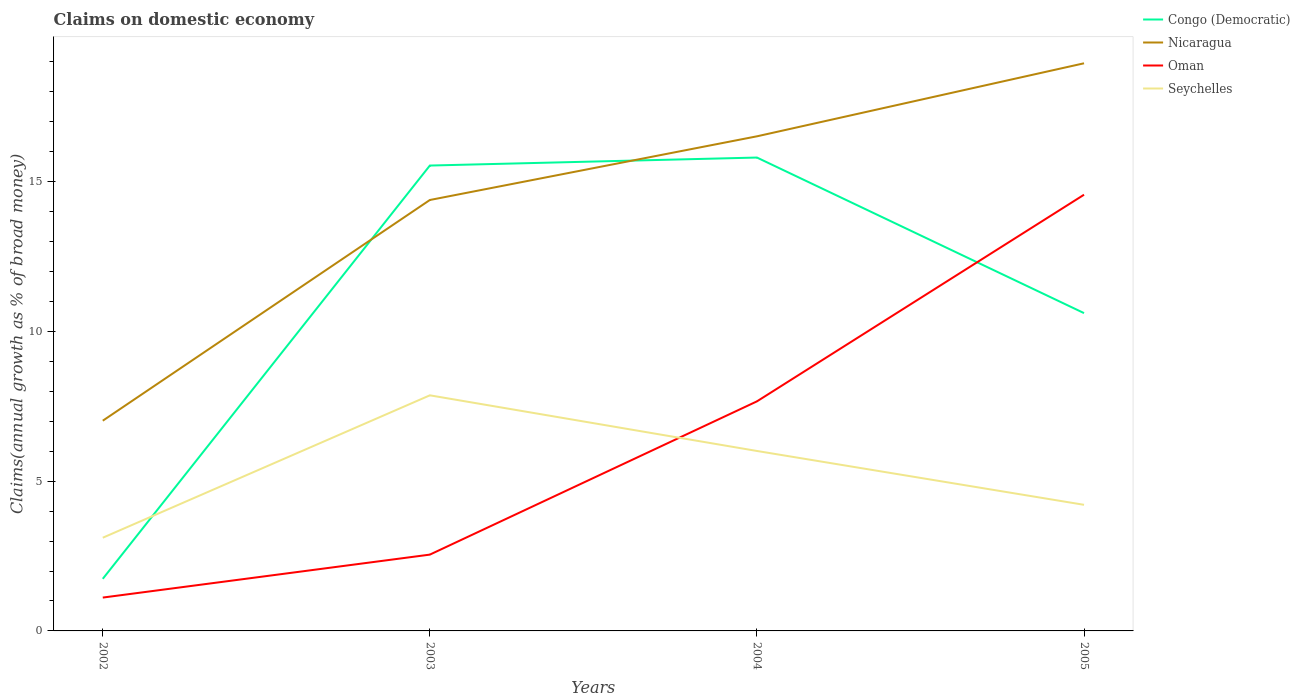Does the line corresponding to Nicaragua intersect with the line corresponding to Seychelles?
Your response must be concise. No. Across all years, what is the maximum percentage of broad money claimed on domestic economy in Oman?
Your response must be concise. 1.11. In which year was the percentage of broad money claimed on domestic economy in Oman maximum?
Give a very brief answer. 2002. What is the total percentage of broad money claimed on domestic economy in Congo (Democratic) in the graph?
Your answer should be compact. -14.06. What is the difference between the highest and the second highest percentage of broad money claimed on domestic economy in Seychelles?
Provide a succinct answer. 4.75. What is the difference between the highest and the lowest percentage of broad money claimed on domestic economy in Congo (Democratic)?
Your answer should be compact. 2. Are the values on the major ticks of Y-axis written in scientific E-notation?
Your answer should be very brief. No. Does the graph contain grids?
Give a very brief answer. No. How many legend labels are there?
Your answer should be very brief. 4. What is the title of the graph?
Offer a very short reply. Claims on domestic economy. Does "Bulgaria" appear as one of the legend labels in the graph?
Your response must be concise. No. What is the label or title of the Y-axis?
Your answer should be very brief. Claims(annual growth as % of broad money). What is the Claims(annual growth as % of broad money) of Congo (Democratic) in 2002?
Provide a succinct answer. 1.74. What is the Claims(annual growth as % of broad money) of Nicaragua in 2002?
Your answer should be compact. 7.02. What is the Claims(annual growth as % of broad money) in Oman in 2002?
Offer a very short reply. 1.11. What is the Claims(annual growth as % of broad money) in Seychelles in 2002?
Provide a succinct answer. 3.11. What is the Claims(annual growth as % of broad money) in Congo (Democratic) in 2003?
Make the answer very short. 15.53. What is the Claims(annual growth as % of broad money) of Nicaragua in 2003?
Provide a succinct answer. 14.38. What is the Claims(annual growth as % of broad money) in Oman in 2003?
Your answer should be very brief. 2.55. What is the Claims(annual growth as % of broad money) of Seychelles in 2003?
Give a very brief answer. 7.86. What is the Claims(annual growth as % of broad money) in Congo (Democratic) in 2004?
Your answer should be very brief. 15.8. What is the Claims(annual growth as % of broad money) in Nicaragua in 2004?
Make the answer very short. 16.51. What is the Claims(annual growth as % of broad money) of Oman in 2004?
Your response must be concise. 7.66. What is the Claims(annual growth as % of broad money) of Seychelles in 2004?
Give a very brief answer. 6.01. What is the Claims(annual growth as % of broad money) in Congo (Democratic) in 2005?
Give a very brief answer. 10.61. What is the Claims(annual growth as % of broad money) in Nicaragua in 2005?
Keep it short and to the point. 18.95. What is the Claims(annual growth as % of broad money) of Oman in 2005?
Make the answer very short. 14.56. What is the Claims(annual growth as % of broad money) in Seychelles in 2005?
Ensure brevity in your answer.  4.21. Across all years, what is the maximum Claims(annual growth as % of broad money) of Congo (Democratic)?
Offer a very short reply. 15.8. Across all years, what is the maximum Claims(annual growth as % of broad money) of Nicaragua?
Keep it short and to the point. 18.95. Across all years, what is the maximum Claims(annual growth as % of broad money) of Oman?
Keep it short and to the point. 14.56. Across all years, what is the maximum Claims(annual growth as % of broad money) of Seychelles?
Keep it short and to the point. 7.86. Across all years, what is the minimum Claims(annual growth as % of broad money) in Congo (Democratic)?
Ensure brevity in your answer.  1.74. Across all years, what is the minimum Claims(annual growth as % of broad money) of Nicaragua?
Offer a very short reply. 7.02. Across all years, what is the minimum Claims(annual growth as % of broad money) in Oman?
Offer a terse response. 1.11. Across all years, what is the minimum Claims(annual growth as % of broad money) of Seychelles?
Your answer should be compact. 3.11. What is the total Claims(annual growth as % of broad money) of Congo (Democratic) in the graph?
Make the answer very short. 43.68. What is the total Claims(annual growth as % of broad money) of Nicaragua in the graph?
Ensure brevity in your answer.  56.86. What is the total Claims(annual growth as % of broad money) of Oman in the graph?
Keep it short and to the point. 25.88. What is the total Claims(annual growth as % of broad money) of Seychelles in the graph?
Your response must be concise. 21.19. What is the difference between the Claims(annual growth as % of broad money) in Congo (Democratic) in 2002 and that in 2003?
Your answer should be compact. -13.79. What is the difference between the Claims(annual growth as % of broad money) of Nicaragua in 2002 and that in 2003?
Provide a short and direct response. -7.37. What is the difference between the Claims(annual growth as % of broad money) in Oman in 2002 and that in 2003?
Ensure brevity in your answer.  -1.43. What is the difference between the Claims(annual growth as % of broad money) of Seychelles in 2002 and that in 2003?
Ensure brevity in your answer.  -4.75. What is the difference between the Claims(annual growth as % of broad money) in Congo (Democratic) in 2002 and that in 2004?
Your answer should be compact. -14.06. What is the difference between the Claims(annual growth as % of broad money) of Nicaragua in 2002 and that in 2004?
Provide a short and direct response. -9.49. What is the difference between the Claims(annual growth as % of broad money) in Oman in 2002 and that in 2004?
Offer a very short reply. -6.55. What is the difference between the Claims(annual growth as % of broad money) of Seychelles in 2002 and that in 2004?
Offer a very short reply. -2.9. What is the difference between the Claims(annual growth as % of broad money) in Congo (Democratic) in 2002 and that in 2005?
Offer a very short reply. -8.87. What is the difference between the Claims(annual growth as % of broad money) in Nicaragua in 2002 and that in 2005?
Give a very brief answer. -11.93. What is the difference between the Claims(annual growth as % of broad money) of Oman in 2002 and that in 2005?
Keep it short and to the point. -13.45. What is the difference between the Claims(annual growth as % of broad money) of Seychelles in 2002 and that in 2005?
Your response must be concise. -1.1. What is the difference between the Claims(annual growth as % of broad money) in Congo (Democratic) in 2003 and that in 2004?
Your answer should be compact. -0.27. What is the difference between the Claims(annual growth as % of broad money) in Nicaragua in 2003 and that in 2004?
Your answer should be very brief. -2.13. What is the difference between the Claims(annual growth as % of broad money) in Oman in 2003 and that in 2004?
Ensure brevity in your answer.  -5.12. What is the difference between the Claims(annual growth as % of broad money) in Seychelles in 2003 and that in 2004?
Offer a very short reply. 1.86. What is the difference between the Claims(annual growth as % of broad money) in Congo (Democratic) in 2003 and that in 2005?
Provide a short and direct response. 4.93. What is the difference between the Claims(annual growth as % of broad money) of Nicaragua in 2003 and that in 2005?
Your answer should be compact. -4.56. What is the difference between the Claims(annual growth as % of broad money) in Oman in 2003 and that in 2005?
Provide a succinct answer. -12.01. What is the difference between the Claims(annual growth as % of broad money) in Seychelles in 2003 and that in 2005?
Your response must be concise. 3.65. What is the difference between the Claims(annual growth as % of broad money) in Congo (Democratic) in 2004 and that in 2005?
Make the answer very short. 5.19. What is the difference between the Claims(annual growth as % of broad money) in Nicaragua in 2004 and that in 2005?
Your answer should be compact. -2.44. What is the difference between the Claims(annual growth as % of broad money) of Oman in 2004 and that in 2005?
Offer a terse response. -6.9. What is the difference between the Claims(annual growth as % of broad money) in Seychelles in 2004 and that in 2005?
Make the answer very short. 1.8. What is the difference between the Claims(annual growth as % of broad money) of Congo (Democratic) in 2002 and the Claims(annual growth as % of broad money) of Nicaragua in 2003?
Give a very brief answer. -12.64. What is the difference between the Claims(annual growth as % of broad money) in Congo (Democratic) in 2002 and the Claims(annual growth as % of broad money) in Oman in 2003?
Your response must be concise. -0.81. What is the difference between the Claims(annual growth as % of broad money) of Congo (Democratic) in 2002 and the Claims(annual growth as % of broad money) of Seychelles in 2003?
Your answer should be compact. -6.12. What is the difference between the Claims(annual growth as % of broad money) in Nicaragua in 2002 and the Claims(annual growth as % of broad money) in Oman in 2003?
Provide a succinct answer. 4.47. What is the difference between the Claims(annual growth as % of broad money) in Nicaragua in 2002 and the Claims(annual growth as % of broad money) in Seychelles in 2003?
Offer a terse response. -0.85. What is the difference between the Claims(annual growth as % of broad money) of Oman in 2002 and the Claims(annual growth as % of broad money) of Seychelles in 2003?
Keep it short and to the point. -6.75. What is the difference between the Claims(annual growth as % of broad money) of Congo (Democratic) in 2002 and the Claims(annual growth as % of broad money) of Nicaragua in 2004?
Your answer should be compact. -14.77. What is the difference between the Claims(annual growth as % of broad money) of Congo (Democratic) in 2002 and the Claims(annual growth as % of broad money) of Oman in 2004?
Offer a very short reply. -5.92. What is the difference between the Claims(annual growth as % of broad money) in Congo (Democratic) in 2002 and the Claims(annual growth as % of broad money) in Seychelles in 2004?
Provide a succinct answer. -4.27. What is the difference between the Claims(annual growth as % of broad money) of Nicaragua in 2002 and the Claims(annual growth as % of broad money) of Oman in 2004?
Give a very brief answer. -0.65. What is the difference between the Claims(annual growth as % of broad money) in Nicaragua in 2002 and the Claims(annual growth as % of broad money) in Seychelles in 2004?
Your response must be concise. 1.01. What is the difference between the Claims(annual growth as % of broad money) in Oman in 2002 and the Claims(annual growth as % of broad money) in Seychelles in 2004?
Your answer should be very brief. -4.89. What is the difference between the Claims(annual growth as % of broad money) in Congo (Democratic) in 2002 and the Claims(annual growth as % of broad money) in Nicaragua in 2005?
Give a very brief answer. -17.21. What is the difference between the Claims(annual growth as % of broad money) of Congo (Democratic) in 2002 and the Claims(annual growth as % of broad money) of Oman in 2005?
Offer a terse response. -12.82. What is the difference between the Claims(annual growth as % of broad money) of Congo (Democratic) in 2002 and the Claims(annual growth as % of broad money) of Seychelles in 2005?
Keep it short and to the point. -2.47. What is the difference between the Claims(annual growth as % of broad money) of Nicaragua in 2002 and the Claims(annual growth as % of broad money) of Oman in 2005?
Your response must be concise. -7.54. What is the difference between the Claims(annual growth as % of broad money) in Nicaragua in 2002 and the Claims(annual growth as % of broad money) in Seychelles in 2005?
Ensure brevity in your answer.  2.81. What is the difference between the Claims(annual growth as % of broad money) in Oman in 2002 and the Claims(annual growth as % of broad money) in Seychelles in 2005?
Offer a very short reply. -3.1. What is the difference between the Claims(annual growth as % of broad money) in Congo (Democratic) in 2003 and the Claims(annual growth as % of broad money) in Nicaragua in 2004?
Your response must be concise. -0.98. What is the difference between the Claims(annual growth as % of broad money) of Congo (Democratic) in 2003 and the Claims(annual growth as % of broad money) of Oman in 2004?
Provide a short and direct response. 7.87. What is the difference between the Claims(annual growth as % of broad money) in Congo (Democratic) in 2003 and the Claims(annual growth as % of broad money) in Seychelles in 2004?
Make the answer very short. 9.53. What is the difference between the Claims(annual growth as % of broad money) in Nicaragua in 2003 and the Claims(annual growth as % of broad money) in Oman in 2004?
Your answer should be compact. 6.72. What is the difference between the Claims(annual growth as % of broad money) of Nicaragua in 2003 and the Claims(annual growth as % of broad money) of Seychelles in 2004?
Your response must be concise. 8.38. What is the difference between the Claims(annual growth as % of broad money) of Oman in 2003 and the Claims(annual growth as % of broad money) of Seychelles in 2004?
Offer a very short reply. -3.46. What is the difference between the Claims(annual growth as % of broad money) of Congo (Democratic) in 2003 and the Claims(annual growth as % of broad money) of Nicaragua in 2005?
Make the answer very short. -3.41. What is the difference between the Claims(annual growth as % of broad money) in Congo (Democratic) in 2003 and the Claims(annual growth as % of broad money) in Oman in 2005?
Your response must be concise. 0.97. What is the difference between the Claims(annual growth as % of broad money) of Congo (Democratic) in 2003 and the Claims(annual growth as % of broad money) of Seychelles in 2005?
Keep it short and to the point. 11.32. What is the difference between the Claims(annual growth as % of broad money) of Nicaragua in 2003 and the Claims(annual growth as % of broad money) of Oman in 2005?
Your answer should be compact. -0.18. What is the difference between the Claims(annual growth as % of broad money) in Nicaragua in 2003 and the Claims(annual growth as % of broad money) in Seychelles in 2005?
Give a very brief answer. 10.17. What is the difference between the Claims(annual growth as % of broad money) of Oman in 2003 and the Claims(annual growth as % of broad money) of Seychelles in 2005?
Provide a short and direct response. -1.66. What is the difference between the Claims(annual growth as % of broad money) in Congo (Democratic) in 2004 and the Claims(annual growth as % of broad money) in Nicaragua in 2005?
Offer a very short reply. -3.15. What is the difference between the Claims(annual growth as % of broad money) of Congo (Democratic) in 2004 and the Claims(annual growth as % of broad money) of Oman in 2005?
Give a very brief answer. 1.24. What is the difference between the Claims(annual growth as % of broad money) of Congo (Democratic) in 2004 and the Claims(annual growth as % of broad money) of Seychelles in 2005?
Provide a succinct answer. 11.59. What is the difference between the Claims(annual growth as % of broad money) in Nicaragua in 2004 and the Claims(annual growth as % of broad money) in Oman in 2005?
Provide a short and direct response. 1.95. What is the difference between the Claims(annual growth as % of broad money) of Nicaragua in 2004 and the Claims(annual growth as % of broad money) of Seychelles in 2005?
Offer a terse response. 12.3. What is the difference between the Claims(annual growth as % of broad money) of Oman in 2004 and the Claims(annual growth as % of broad money) of Seychelles in 2005?
Your answer should be very brief. 3.45. What is the average Claims(annual growth as % of broad money) in Congo (Democratic) per year?
Ensure brevity in your answer.  10.92. What is the average Claims(annual growth as % of broad money) of Nicaragua per year?
Provide a short and direct response. 14.21. What is the average Claims(annual growth as % of broad money) of Oman per year?
Make the answer very short. 6.47. What is the average Claims(annual growth as % of broad money) of Seychelles per year?
Offer a terse response. 5.3. In the year 2002, what is the difference between the Claims(annual growth as % of broad money) in Congo (Democratic) and Claims(annual growth as % of broad money) in Nicaragua?
Offer a terse response. -5.28. In the year 2002, what is the difference between the Claims(annual growth as % of broad money) in Congo (Democratic) and Claims(annual growth as % of broad money) in Oman?
Make the answer very short. 0.63. In the year 2002, what is the difference between the Claims(annual growth as % of broad money) in Congo (Democratic) and Claims(annual growth as % of broad money) in Seychelles?
Provide a succinct answer. -1.37. In the year 2002, what is the difference between the Claims(annual growth as % of broad money) of Nicaragua and Claims(annual growth as % of broad money) of Oman?
Provide a succinct answer. 5.9. In the year 2002, what is the difference between the Claims(annual growth as % of broad money) of Nicaragua and Claims(annual growth as % of broad money) of Seychelles?
Ensure brevity in your answer.  3.91. In the year 2002, what is the difference between the Claims(annual growth as % of broad money) in Oman and Claims(annual growth as % of broad money) in Seychelles?
Make the answer very short. -2. In the year 2003, what is the difference between the Claims(annual growth as % of broad money) in Congo (Democratic) and Claims(annual growth as % of broad money) in Nicaragua?
Give a very brief answer. 1.15. In the year 2003, what is the difference between the Claims(annual growth as % of broad money) in Congo (Democratic) and Claims(annual growth as % of broad money) in Oman?
Offer a terse response. 12.99. In the year 2003, what is the difference between the Claims(annual growth as % of broad money) in Congo (Democratic) and Claims(annual growth as % of broad money) in Seychelles?
Your response must be concise. 7.67. In the year 2003, what is the difference between the Claims(annual growth as % of broad money) in Nicaragua and Claims(annual growth as % of broad money) in Oman?
Keep it short and to the point. 11.84. In the year 2003, what is the difference between the Claims(annual growth as % of broad money) of Nicaragua and Claims(annual growth as % of broad money) of Seychelles?
Your answer should be compact. 6.52. In the year 2003, what is the difference between the Claims(annual growth as % of broad money) of Oman and Claims(annual growth as % of broad money) of Seychelles?
Keep it short and to the point. -5.32. In the year 2004, what is the difference between the Claims(annual growth as % of broad money) in Congo (Democratic) and Claims(annual growth as % of broad money) in Nicaragua?
Your answer should be very brief. -0.71. In the year 2004, what is the difference between the Claims(annual growth as % of broad money) of Congo (Democratic) and Claims(annual growth as % of broad money) of Oman?
Make the answer very short. 8.14. In the year 2004, what is the difference between the Claims(annual growth as % of broad money) in Congo (Democratic) and Claims(annual growth as % of broad money) in Seychelles?
Keep it short and to the point. 9.79. In the year 2004, what is the difference between the Claims(annual growth as % of broad money) of Nicaragua and Claims(annual growth as % of broad money) of Oman?
Offer a terse response. 8.85. In the year 2004, what is the difference between the Claims(annual growth as % of broad money) of Nicaragua and Claims(annual growth as % of broad money) of Seychelles?
Offer a terse response. 10.5. In the year 2004, what is the difference between the Claims(annual growth as % of broad money) in Oman and Claims(annual growth as % of broad money) in Seychelles?
Your response must be concise. 1.66. In the year 2005, what is the difference between the Claims(annual growth as % of broad money) in Congo (Democratic) and Claims(annual growth as % of broad money) in Nicaragua?
Your answer should be compact. -8.34. In the year 2005, what is the difference between the Claims(annual growth as % of broad money) of Congo (Democratic) and Claims(annual growth as % of broad money) of Oman?
Your answer should be compact. -3.95. In the year 2005, what is the difference between the Claims(annual growth as % of broad money) in Congo (Democratic) and Claims(annual growth as % of broad money) in Seychelles?
Give a very brief answer. 6.4. In the year 2005, what is the difference between the Claims(annual growth as % of broad money) in Nicaragua and Claims(annual growth as % of broad money) in Oman?
Offer a very short reply. 4.39. In the year 2005, what is the difference between the Claims(annual growth as % of broad money) in Nicaragua and Claims(annual growth as % of broad money) in Seychelles?
Keep it short and to the point. 14.74. In the year 2005, what is the difference between the Claims(annual growth as % of broad money) of Oman and Claims(annual growth as % of broad money) of Seychelles?
Provide a succinct answer. 10.35. What is the ratio of the Claims(annual growth as % of broad money) of Congo (Democratic) in 2002 to that in 2003?
Provide a succinct answer. 0.11. What is the ratio of the Claims(annual growth as % of broad money) in Nicaragua in 2002 to that in 2003?
Give a very brief answer. 0.49. What is the ratio of the Claims(annual growth as % of broad money) of Oman in 2002 to that in 2003?
Make the answer very short. 0.44. What is the ratio of the Claims(annual growth as % of broad money) of Seychelles in 2002 to that in 2003?
Provide a succinct answer. 0.4. What is the ratio of the Claims(annual growth as % of broad money) in Congo (Democratic) in 2002 to that in 2004?
Make the answer very short. 0.11. What is the ratio of the Claims(annual growth as % of broad money) in Nicaragua in 2002 to that in 2004?
Your answer should be compact. 0.42. What is the ratio of the Claims(annual growth as % of broad money) of Oman in 2002 to that in 2004?
Provide a succinct answer. 0.15. What is the ratio of the Claims(annual growth as % of broad money) in Seychelles in 2002 to that in 2004?
Offer a terse response. 0.52. What is the ratio of the Claims(annual growth as % of broad money) of Congo (Democratic) in 2002 to that in 2005?
Your response must be concise. 0.16. What is the ratio of the Claims(annual growth as % of broad money) of Nicaragua in 2002 to that in 2005?
Your response must be concise. 0.37. What is the ratio of the Claims(annual growth as % of broad money) of Oman in 2002 to that in 2005?
Provide a short and direct response. 0.08. What is the ratio of the Claims(annual growth as % of broad money) in Seychelles in 2002 to that in 2005?
Make the answer very short. 0.74. What is the ratio of the Claims(annual growth as % of broad money) of Congo (Democratic) in 2003 to that in 2004?
Your answer should be compact. 0.98. What is the ratio of the Claims(annual growth as % of broad money) of Nicaragua in 2003 to that in 2004?
Your response must be concise. 0.87. What is the ratio of the Claims(annual growth as % of broad money) in Oman in 2003 to that in 2004?
Make the answer very short. 0.33. What is the ratio of the Claims(annual growth as % of broad money) in Seychelles in 2003 to that in 2004?
Provide a succinct answer. 1.31. What is the ratio of the Claims(annual growth as % of broad money) in Congo (Democratic) in 2003 to that in 2005?
Offer a terse response. 1.46. What is the ratio of the Claims(annual growth as % of broad money) of Nicaragua in 2003 to that in 2005?
Give a very brief answer. 0.76. What is the ratio of the Claims(annual growth as % of broad money) in Oman in 2003 to that in 2005?
Provide a succinct answer. 0.17. What is the ratio of the Claims(annual growth as % of broad money) in Seychelles in 2003 to that in 2005?
Give a very brief answer. 1.87. What is the ratio of the Claims(annual growth as % of broad money) of Congo (Democratic) in 2004 to that in 2005?
Make the answer very short. 1.49. What is the ratio of the Claims(annual growth as % of broad money) in Nicaragua in 2004 to that in 2005?
Make the answer very short. 0.87. What is the ratio of the Claims(annual growth as % of broad money) in Oman in 2004 to that in 2005?
Ensure brevity in your answer.  0.53. What is the ratio of the Claims(annual growth as % of broad money) in Seychelles in 2004 to that in 2005?
Your answer should be compact. 1.43. What is the difference between the highest and the second highest Claims(annual growth as % of broad money) in Congo (Democratic)?
Give a very brief answer. 0.27. What is the difference between the highest and the second highest Claims(annual growth as % of broad money) in Nicaragua?
Ensure brevity in your answer.  2.44. What is the difference between the highest and the second highest Claims(annual growth as % of broad money) of Oman?
Ensure brevity in your answer.  6.9. What is the difference between the highest and the second highest Claims(annual growth as % of broad money) in Seychelles?
Give a very brief answer. 1.86. What is the difference between the highest and the lowest Claims(annual growth as % of broad money) in Congo (Democratic)?
Make the answer very short. 14.06. What is the difference between the highest and the lowest Claims(annual growth as % of broad money) in Nicaragua?
Your response must be concise. 11.93. What is the difference between the highest and the lowest Claims(annual growth as % of broad money) of Oman?
Make the answer very short. 13.45. What is the difference between the highest and the lowest Claims(annual growth as % of broad money) of Seychelles?
Provide a succinct answer. 4.75. 